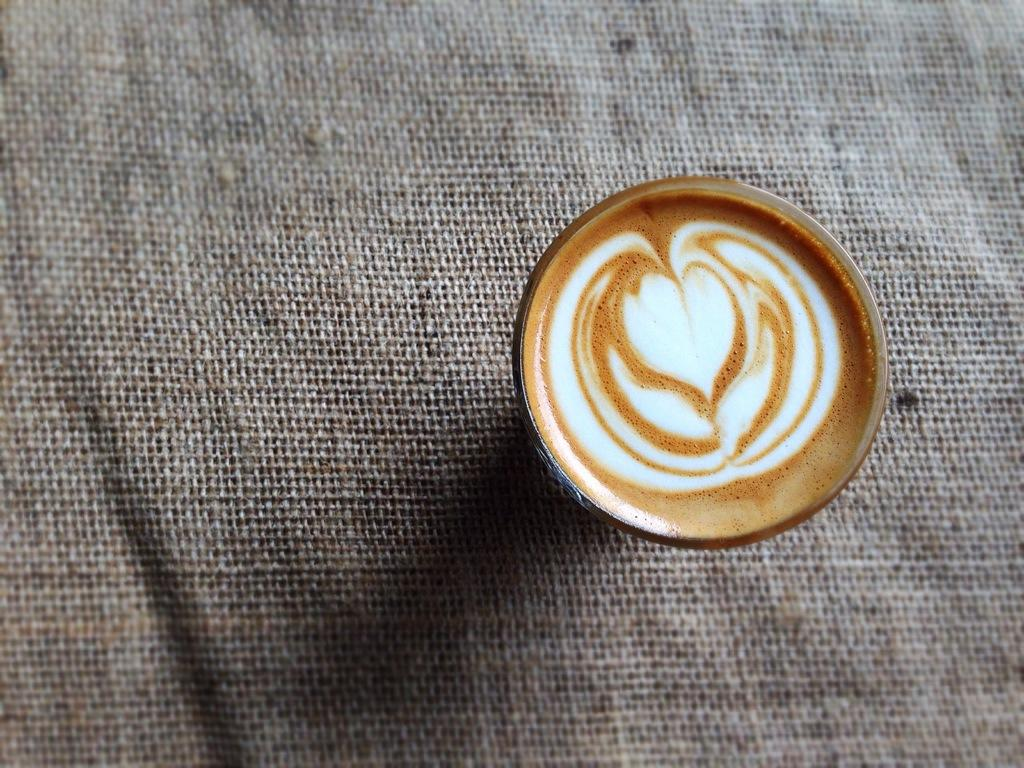What is in the cup that is visible in the image? The cup contains coffee. What is the cup placed on in the image? The cup is on a brown-colored cloth. How many clocks are hanging on the wall behind the cup in the image? There is no wall or clock present in the image; it only shows a cup with coffee on a brown-colored cloth. 